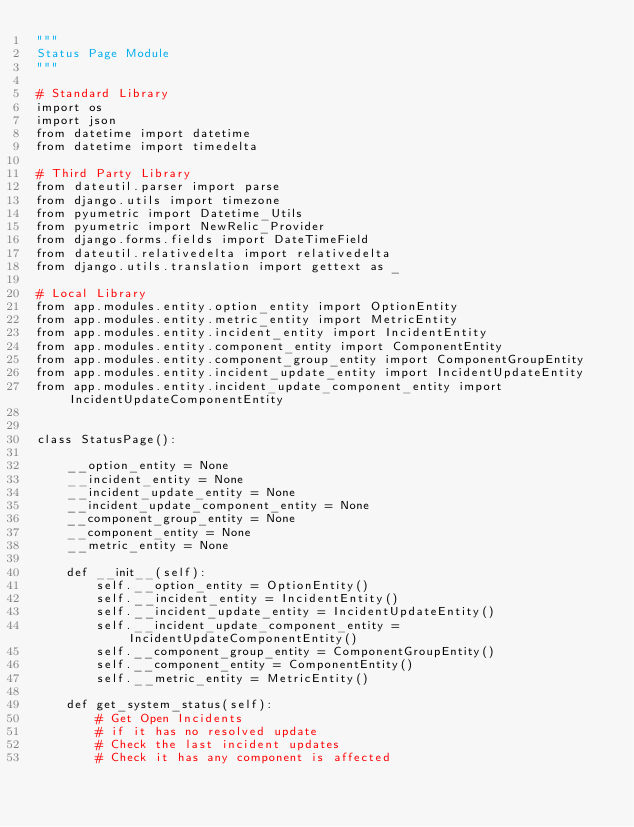<code> <loc_0><loc_0><loc_500><loc_500><_Python_>"""
Status Page Module
"""

# Standard Library
import os
import json
from datetime import datetime
from datetime import timedelta

# Third Party Library
from dateutil.parser import parse
from django.utils import timezone
from pyumetric import Datetime_Utils
from pyumetric import NewRelic_Provider
from django.forms.fields import DateTimeField
from dateutil.relativedelta import relativedelta
from django.utils.translation import gettext as _

# Local Library
from app.modules.entity.option_entity import OptionEntity
from app.modules.entity.metric_entity import MetricEntity
from app.modules.entity.incident_entity import IncidentEntity
from app.modules.entity.component_entity import ComponentEntity
from app.modules.entity.component_group_entity import ComponentGroupEntity
from app.modules.entity.incident_update_entity import IncidentUpdateEntity
from app.modules.entity.incident_update_component_entity import IncidentUpdateComponentEntity


class StatusPage():

    __option_entity = None
    __incident_entity = None
    __incident_update_entity = None
    __incident_update_component_entity = None
    __component_group_entity = None
    __component_entity = None
    __metric_entity = None

    def __init__(self):
        self.__option_entity = OptionEntity()
        self.__incident_entity = IncidentEntity()
        self.__incident_update_entity = IncidentUpdateEntity()
        self.__incident_update_component_entity = IncidentUpdateComponentEntity()
        self.__component_group_entity = ComponentGroupEntity()
        self.__component_entity = ComponentEntity()
        self.__metric_entity = MetricEntity()

    def get_system_status(self):
        # Get Open Incidents
        # if it has no resolved update
        # Check the last incident updates
        # Check it has any component is affected</code> 